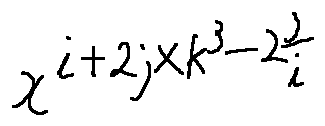<formula> <loc_0><loc_0><loc_500><loc_500>x ^ { i + 2 j \times k ^ { 3 } - 2 \frac { j } { i } }</formula> 